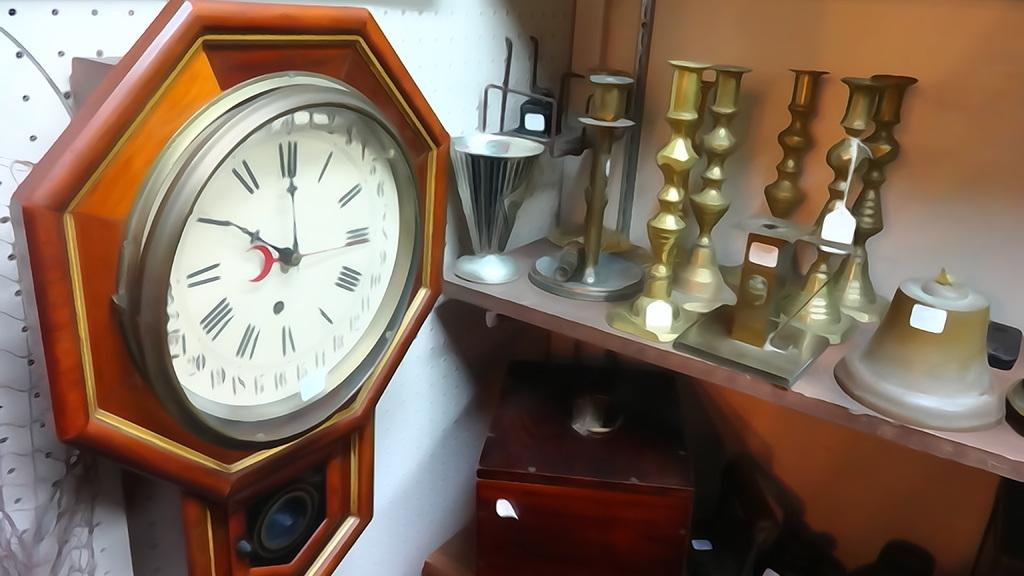What is the main object in the image? There is a wall clock in the image. Where is the wall clock located? The wall clock is on a wall. What else can be seen on the right side of the image? There is a group of objects on racks in the image. What type of star can be seen reacting to the wall clock in the image? There is no star present in the image, and therefore no reaction to the wall clock can be observed. 